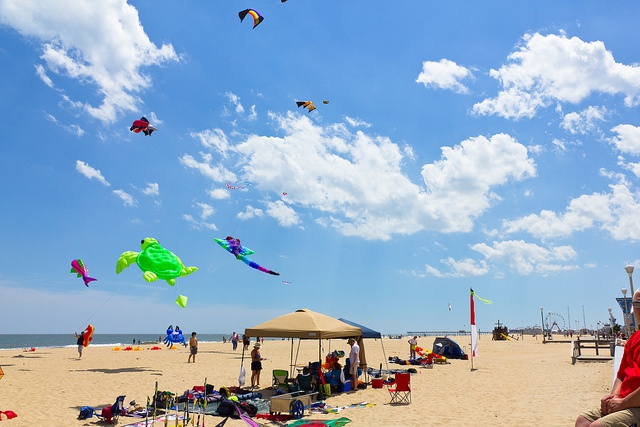Describe the objects in this image and their specific colors. I can see umbrella in lavender, tan, and maroon tones, people in lavender, maroon, red, and brown tones, kite in lavender, lime, and green tones, kite in lavender, lightblue, darkblue, and blue tones, and chair in lavender, maroon, tan, and gray tones in this image. 